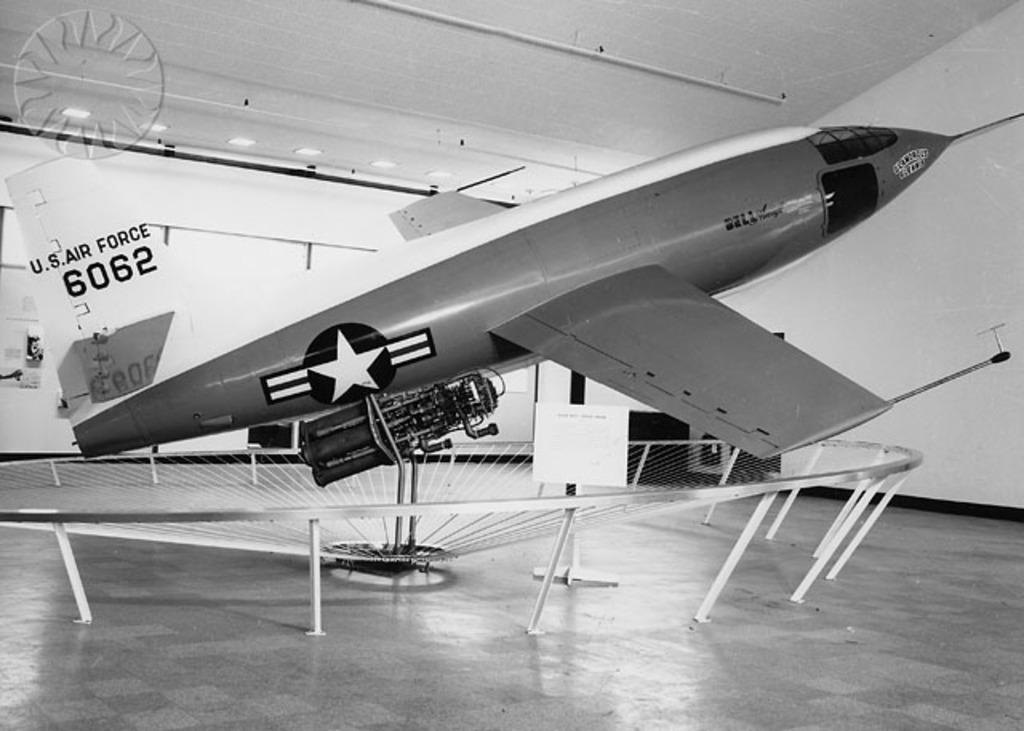What is the main subject of the image? The main subject of the image is an airplane. What can be seen in the background of the image? In the background of the image, there are lights on the ceiling and lights on the wall. What is the color scheme of the image? The image is black and white in color. What type of selection is being made by the airplane in the image? There is no indication in the image that the airplane is making a selection, as airplanes do not have the ability to make selections. 